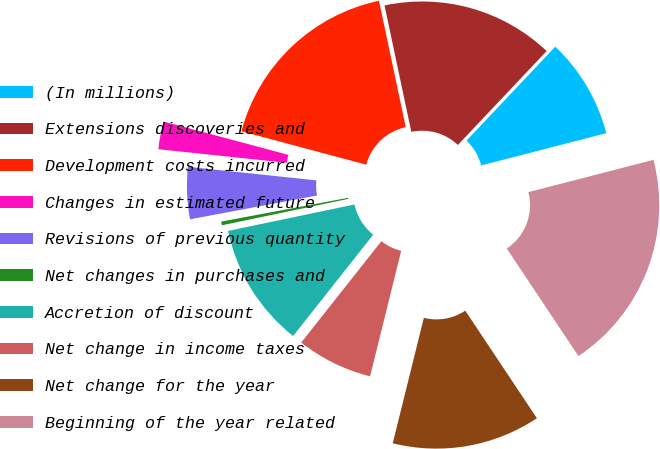<chart> <loc_0><loc_0><loc_500><loc_500><pie_chart><fcel>(In millions)<fcel>Extensions discoveries and<fcel>Development costs incurred<fcel>Changes in estimated future<fcel>Revisions of previous quantity<fcel>Net changes in purchases and<fcel>Accretion of discount<fcel>Net change in income taxes<fcel>Net change for the year<fcel>Beginning of the year related<nl><fcel>8.93%<fcel>15.37%<fcel>17.52%<fcel>2.48%<fcel>4.63%<fcel>0.33%<fcel>11.07%<fcel>6.78%<fcel>13.22%<fcel>19.67%<nl></chart> 